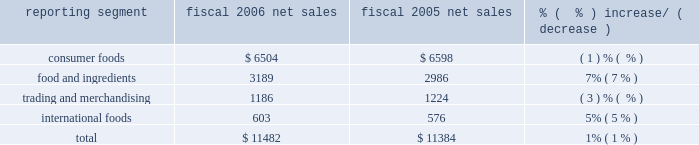Years 2002 , 2003 , 2004 , and the first two quarters of fiscal 2005 .
The restatement related to tax matters .
The company provided information to the sec staff relating to the facts and circumstances surrounding the restatement .
On july 28 , 2006 , the company filed an amendment to its annual report on form 10-k for the fiscal year ended may 29 , 2005 .
The filing amended item 6 .
Selected financial data and exhibit 12 , computation of ratios of earnings to fixed charges , for fiscal year 2001 , and certain restated financial information for fiscal years 1999 and 2000 , all related to the application of certain of the company 2019s reserves for the three years and fiscal year 1999 income tax expense .
The company provided information to the sec staff relating to the facts and circumstances surrounding the amended filing .
The company reached an agreement with the sec staff concerning matters associated with these amended filings .
That proposed settlement was approved by the securities and exchange commission on july 17 , 2007 .
On july 24 , 2007 , the sec filed its complaint against the company in the united states district court for the district of colorado , followed by an executed consent , which without the company admitting or denying the allegations of the complaint , reflects the terms of the settlement , including payment by the company of a civil penalty of $ 45 million and the company 2019s agreement to be permanently enjoined from violating certain provisions of the federal securities laws .
Additionally , the company made approximately $ 2 million in indemnity payments on behalf of former employees concluding separate settlements with the sec .
The company recorded charges of $ 25 million in fiscal 2004 , $ 21.5 million in the third quarter of fiscal 2005 , and $ 1.2 million in the first quarter of fiscal 2007 in connection with the expected settlement of these matters .
Three purported class actions were filed in united states district court for nebraska , rantala v .
Conagra foods , inc. , et .
Al. , case no .
805cv349 , and bright v .
Conagra foods , inc. , et .
Al. , case no .
805cv348 on july 18 , 2005 , and boyd v .
Conagra foods , inc. , et .
Al. , case no .
805cv386 on august 8 , 2005 .
The lawsuits are against the company , its directors and its employee benefits committee on behalf of participants in the company 2019s employee retirement income savings plans .
The lawsuits allege violations of the employee retirement income security act ( erisa ) in connection with the events resulting in the company 2019s april 2005 restatement of its financial statements and related matters .
The company has reached a settlement with the plaintiffs in these actions subject to court approval .
The settlement includes a $ 4 million payment , most of which will be paid by an insurer .
The company has also agreed to make certain prospective changes to its benefit plans as part of the settlement .
2006 vs .
2005 net sales ( $ in millions ) reporting segment fiscal 2006 net sales fiscal 2005 net sales % (  % ) increase/ ( decrease ) .
Overall , company net sales increased $ 98 million to $ 11.5 billion in fiscal 2006 , primarily reflecting favorable results in the food and ingredients and international foods segments .
Price increases driven by higher input costs for potatoes , wheat milling and dehydrated vegetables within the food and ingredients segment , coupled with the strength of foreign currencies within the international foods segment enhanced net sales .
These increases were partially offset by volume declines in the consumer foods segment , principally related to certain shelf stable brands and declines in the trading and merchandising segment related to decreased volumes and certain divestitures and closures. .
What percentage of total net sales where comprised of food and ingredients in 2005? 
Computations: (2986 / 11384)
Answer: 0.2623. 